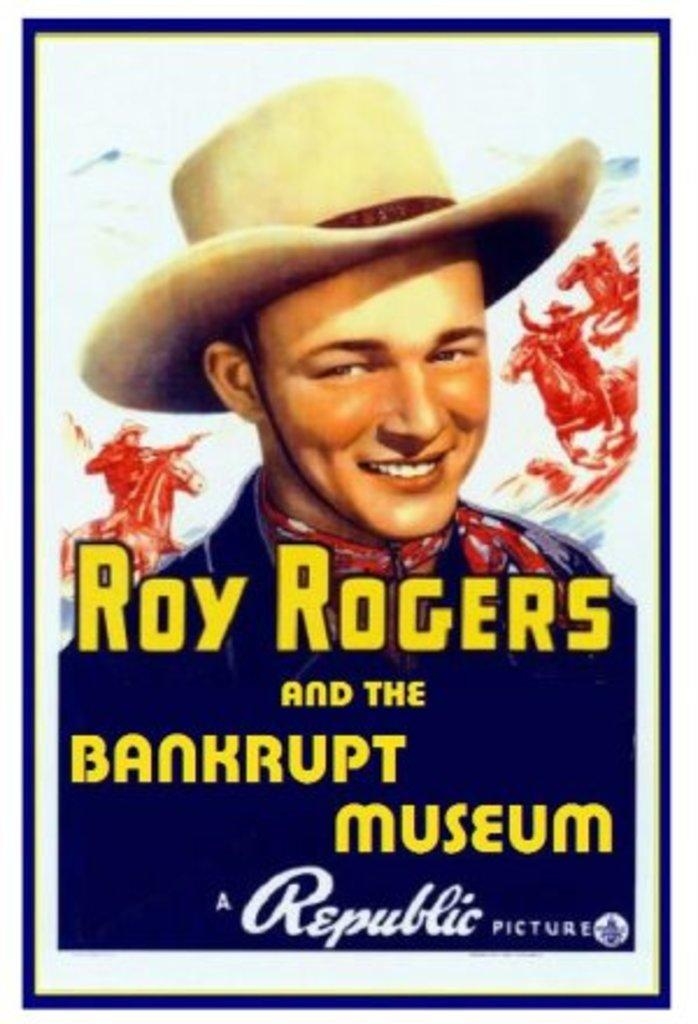<image>
Share a concise interpretation of the image provided. A poster has the name Roy Rogers on it. 